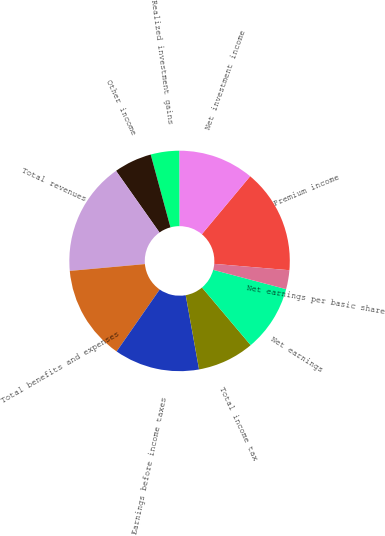Convert chart. <chart><loc_0><loc_0><loc_500><loc_500><pie_chart><fcel>Premium income<fcel>Net investment income<fcel>Realized investment gains<fcel>Other income<fcel>Total revenues<fcel>Total benefits and expenses<fcel>Earnings before income taxes<fcel>Total income tax<fcel>Net earnings<fcel>Net earnings per basic share<nl><fcel>15.28%<fcel>11.11%<fcel>4.17%<fcel>5.56%<fcel>16.67%<fcel>13.89%<fcel>12.5%<fcel>8.33%<fcel>9.72%<fcel>2.78%<nl></chart> 